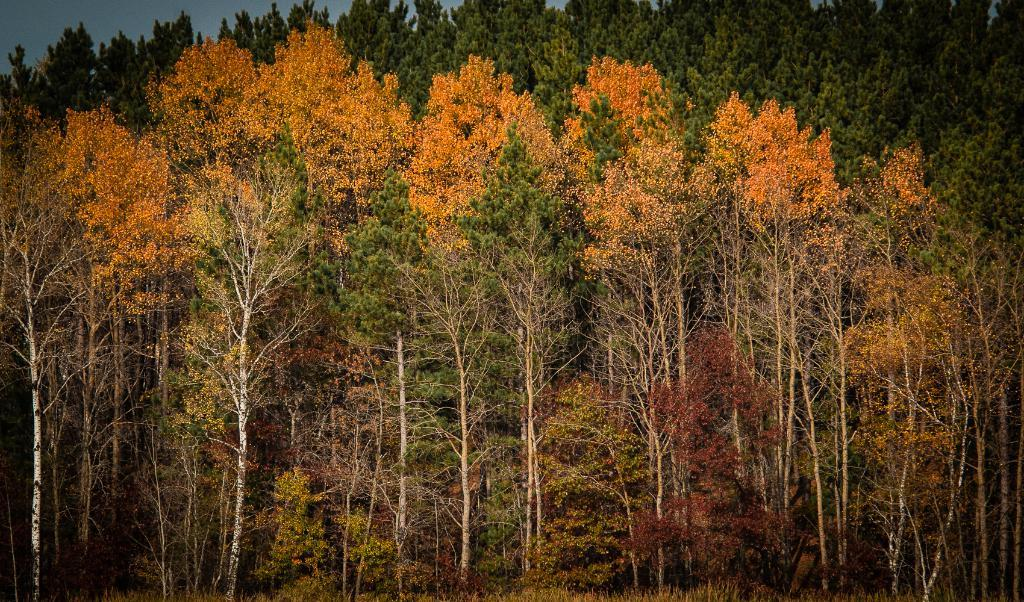What type of vegetation can be seen in the image? There are trees in the image. What day of the week is depicted in the image? There is no specific day of the week depicted in the image, as it only features trees. What type of activity is the tree engaged in within the image? Trees are not capable of engaging in activities like reading or kicking, as they are inanimate objects. 